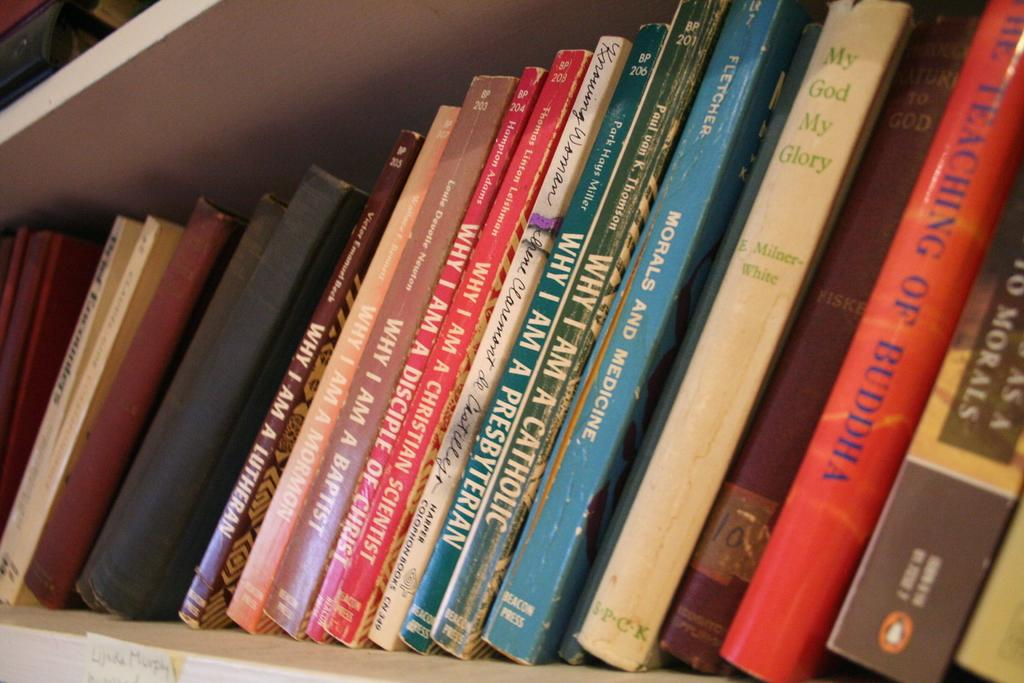<image>
Provide a brief description of the given image. a stack of books with one of them titled 'my god my glory' in green 